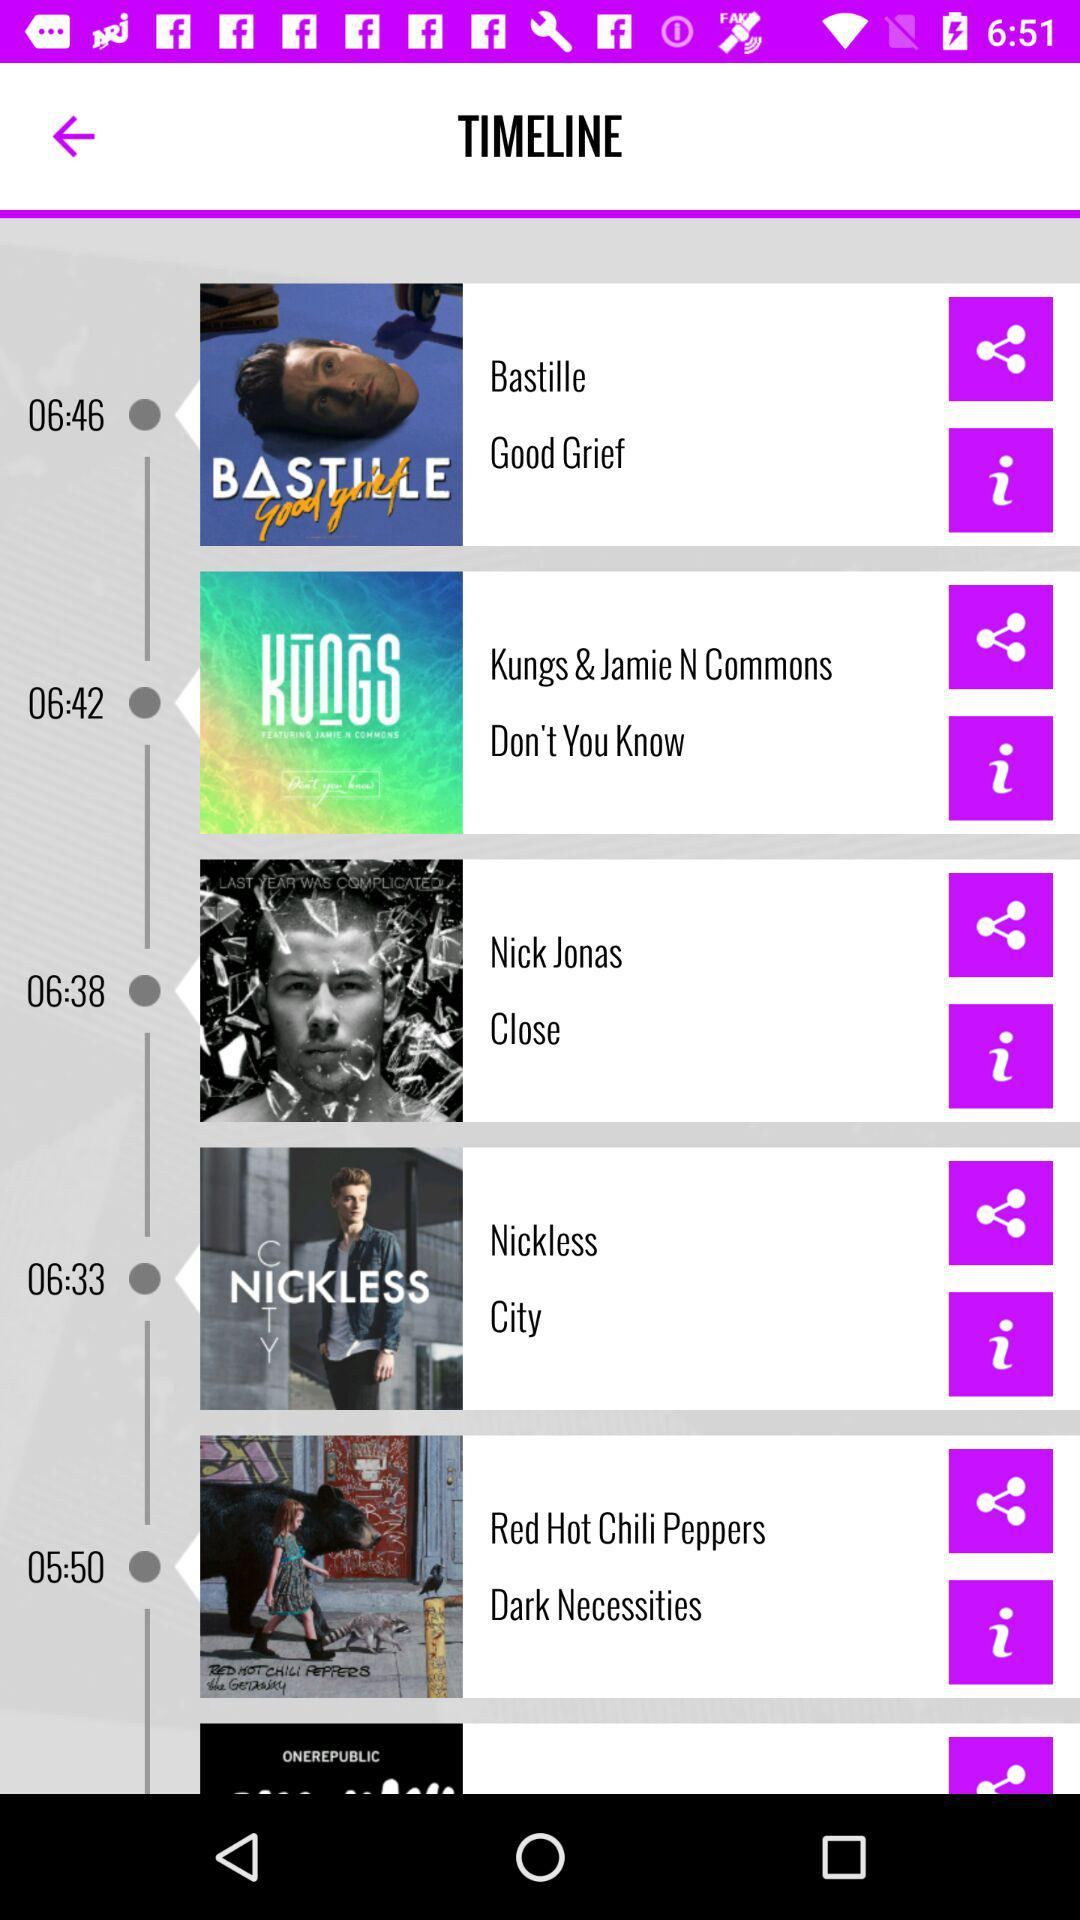Who is the singer of the song "Good Grief"? The singer of the song "Good Grief" is Bastille. 